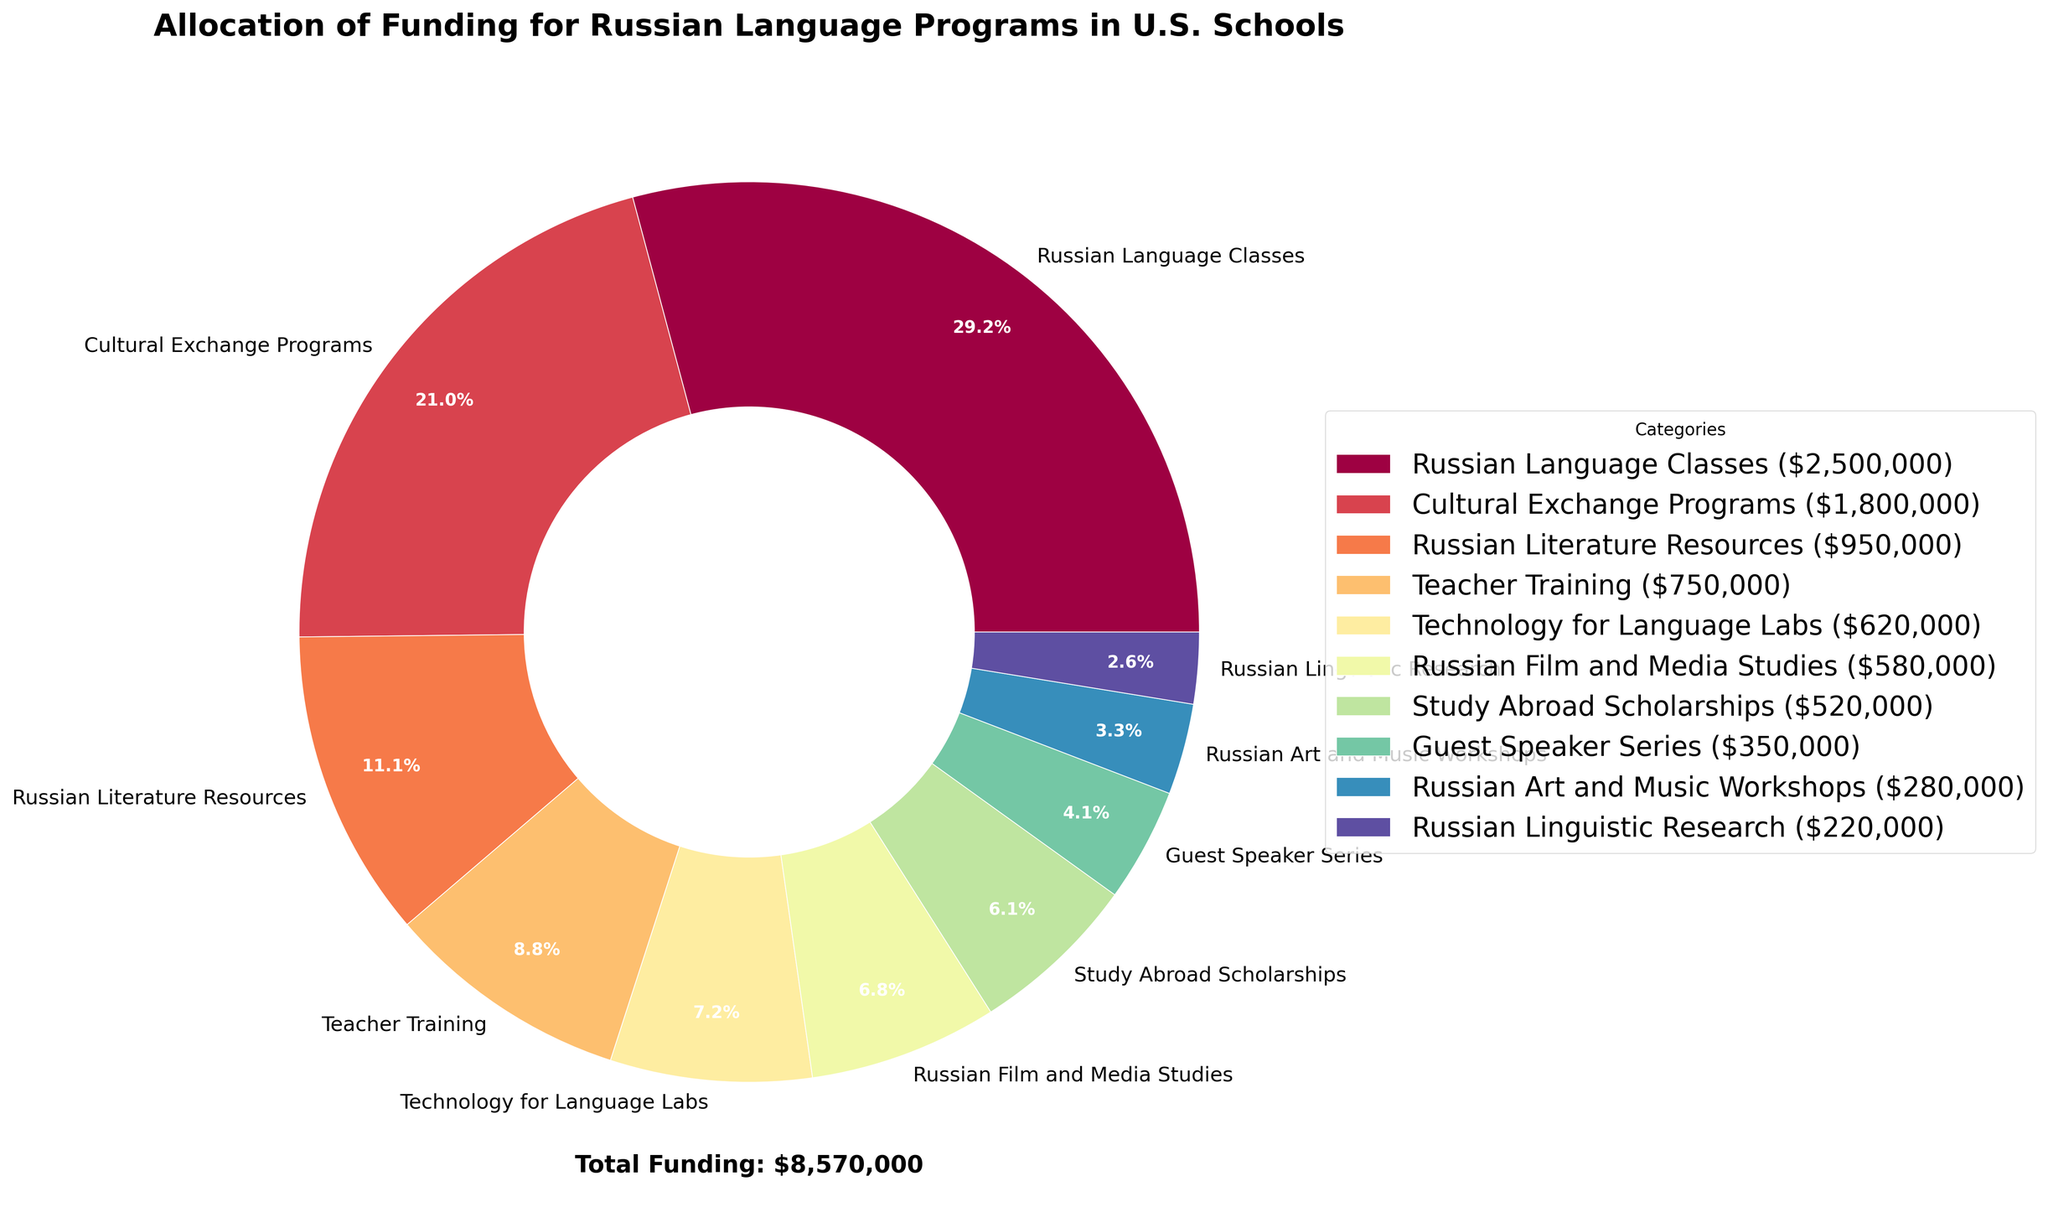Which category receives the highest funding? The category with the largest section in the pie chart indicates the highest funding amount. From the chart, it's the "Russian Language Classes" section.
Answer: Russian Language Classes How much total funding is allocated to Russian Language Programs in U.S. schools? The total funding amount is displayed at the bottom of the pie chart as "Total Funding: $8,178,000".
Answer: $8,178,000 Which category receives less funding: Russian Film and Media Studies or Teacher Training? The section for "Teacher Training" is larger than that for "Russian Film and Media Studies", indicating a higher funding amount for "Teacher Training".
Answer: Russian Film and Media Studies What percentage of the total funding is allocated to Study Abroad Scholarships? The percentage for "Study Abroad Scholarships" is displayed on its section in the pie chart, which is 6.4%.
Answer: 6.4% Combine the funding amounts for Cultural Exchange Programs and Russian Literature Resources. What do you get? Add the funding amounts for the two categories: $1,800,000 (Cultural Exchange Programs) + $950,000 (Russian Literature Resources) = $2,750,000.
Answer: $2,750,000 Compare the funding for Russian Language Classes with that for Cultural Exchange Programs and Teacher Training combined. Which is higher? The funding for "Russian Language Classes" is $2,500,000. The combined funding for "Cultural Exchange Programs" and "Teacher Training" is $1,800,000 + $750,000 = $2,550,000.
Answer: Cultural Exchange Programs and Teacher Training combined What is the total funding amount allocated to Russian Film and Media Studies and Russian Art and Music Workshops together? Add the funding amounts for the two categories: $580,000 (Russian Film and Media Studies) + $280,000 (Russian Art and Music Workshops) = $860,000.
Answer: $860,000 Which category receives nearly double the funding of Russian Art and Music Workshops? The funding for "Russian Art and Music Workshops" is $280,000. "Technology for Language Labs" has $620,000, which is more than double $280,000.
Answer: Technology for Language Labs Which category has the smallest percentage of total funding and what is this percentage? The smallest section in the pie chart represents "Russian Linguistic Research" with 2.7%.
Answer: Russian Linguistic Research, 2.7% What three categories combined have the largest slice of the funding pie? The three largest sections in the pie chart are "Russian Language Classes", "Cultural Exchange Programs", and "Russian Literature Resources".
Answer: Russian Language Classes, Cultural Exchange Programs, Russian Literature Resources 